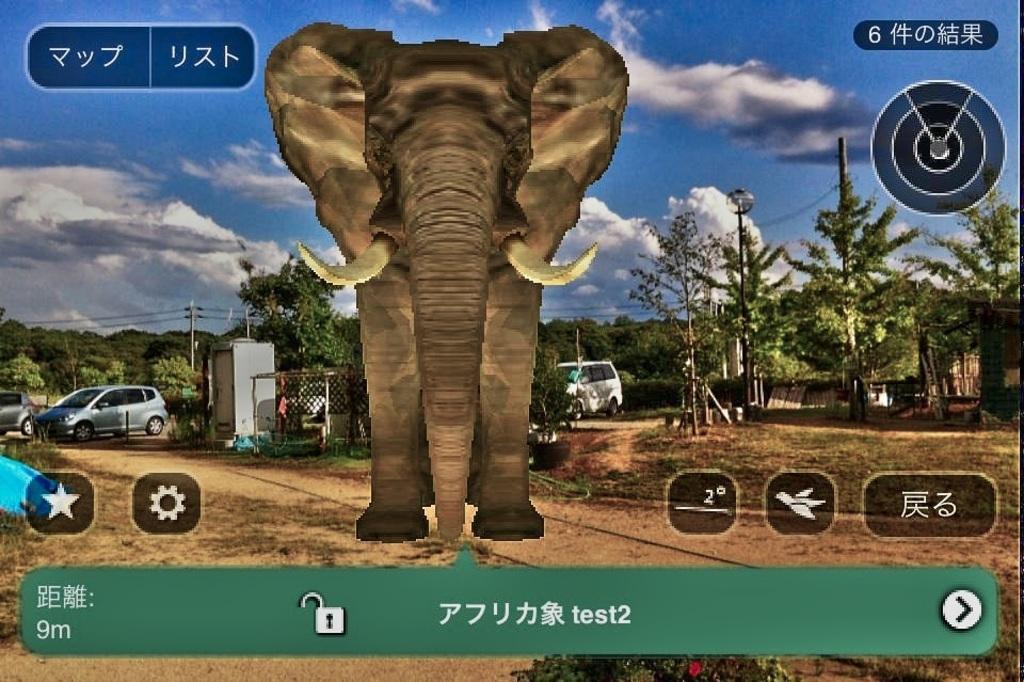Please provide a concise description of this image. This image is an animated image. At the top of the image there is the sky with clouds and there are many trees and plants on the ground. There are a few poles with a few wires and street lights. A few cars are parked on the ground. There is a mesh and there is a transformer. In the middle of the image an elephant is standing on the ground. In this image there are a few symbols and there is a text on it. 